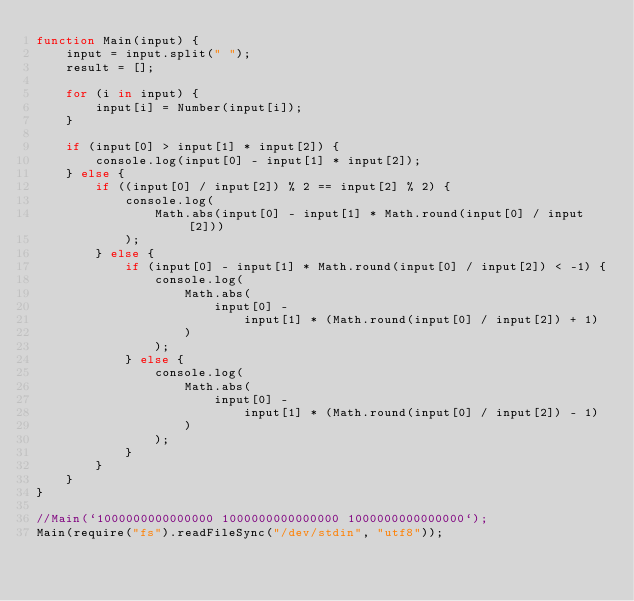Convert code to text. <code><loc_0><loc_0><loc_500><loc_500><_JavaScript_>function Main(input) {
    input = input.split(" ");
    result = [];

    for (i in input) {
        input[i] = Number(input[i]);
    }

    if (input[0] > input[1] * input[2]) {
        console.log(input[0] - input[1] * input[2]);
    } else {
        if ((input[0] / input[2]) % 2 == input[2] % 2) {
            console.log(
                Math.abs(input[0] - input[1] * Math.round(input[0] / input[2]))
            );
        } else {
            if (input[0] - input[1] * Math.round(input[0] / input[2]) < -1) {
                console.log(
                    Math.abs(
                        input[0] -
                            input[1] * (Math.round(input[0] / input[2]) + 1)
                    )
                );
            } else {
                console.log(
                    Math.abs(
                        input[0] -
                            input[1] * (Math.round(input[0] / input[2]) - 1)
                    )
                );
            }
        }
    }
}

//Main(`1000000000000000 1000000000000000 1000000000000000`);
Main(require("fs").readFileSync("/dev/stdin", "utf8"));
</code> 